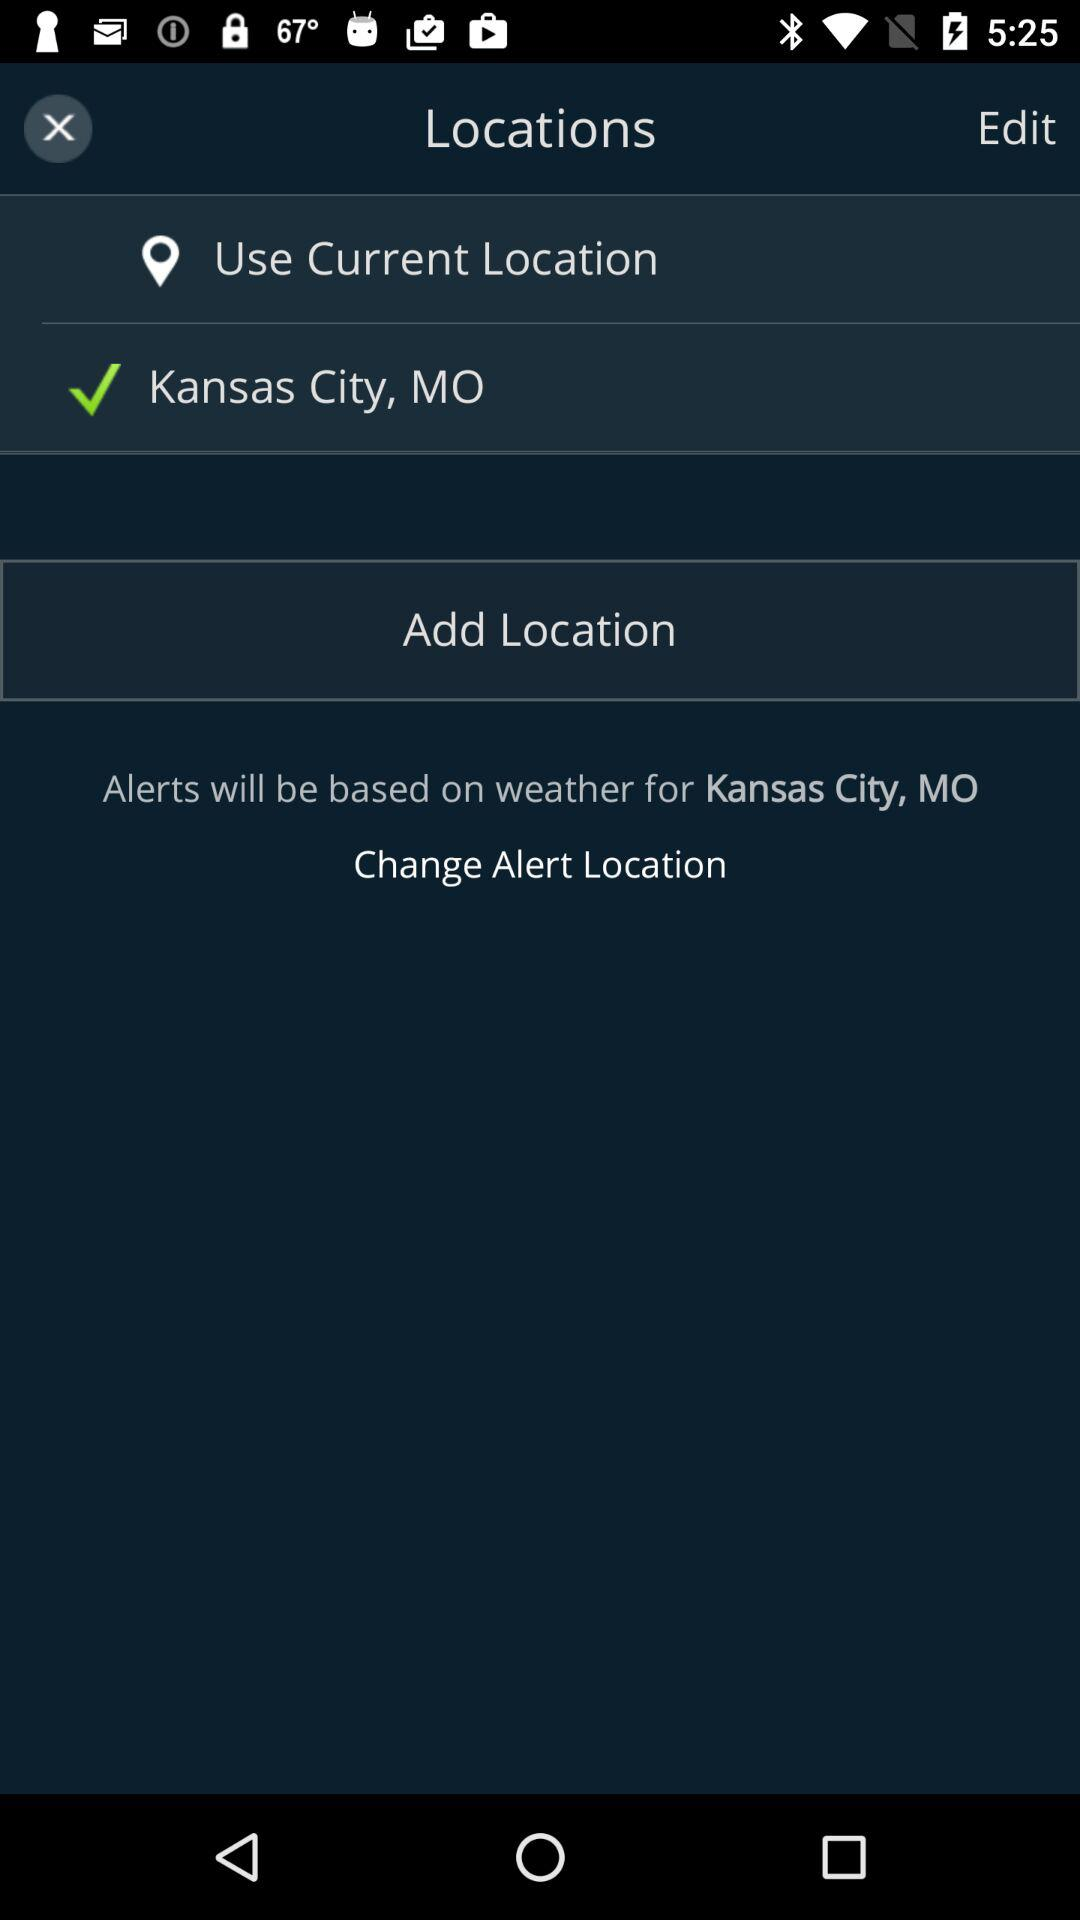What is the selected location? The selected location is Kansas City, MO. 